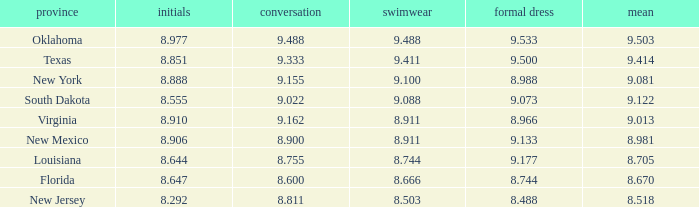 what's the evening gown where preliminaries is 8.977 9.533. 